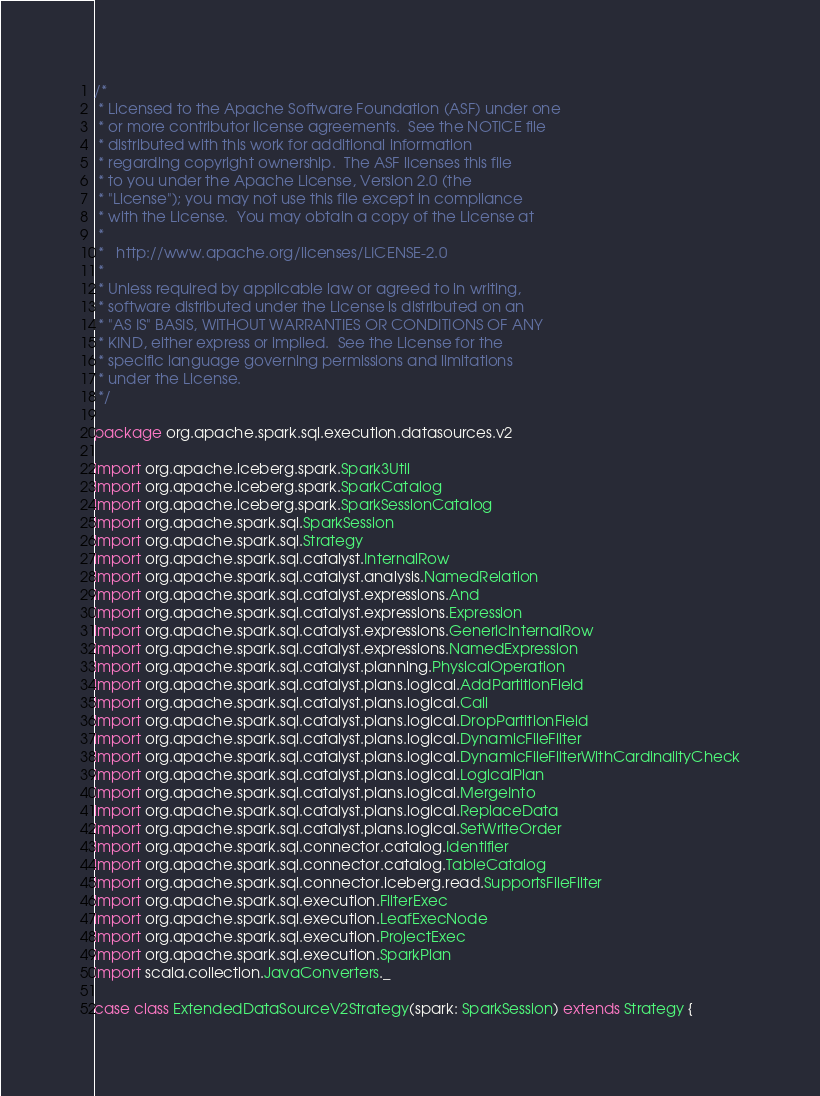Convert code to text. <code><loc_0><loc_0><loc_500><loc_500><_Scala_>/*
 * Licensed to the Apache Software Foundation (ASF) under one
 * or more contributor license agreements.  See the NOTICE file
 * distributed with this work for additional information
 * regarding copyright ownership.  The ASF licenses this file
 * to you under the Apache License, Version 2.0 (the
 * "License"); you may not use this file except in compliance
 * with the License.  You may obtain a copy of the License at
 *
 *   http://www.apache.org/licenses/LICENSE-2.0
 *
 * Unless required by applicable law or agreed to in writing,
 * software distributed under the License is distributed on an
 * "AS IS" BASIS, WITHOUT WARRANTIES OR CONDITIONS OF ANY
 * KIND, either express or implied.  See the License for the
 * specific language governing permissions and limitations
 * under the License.
 */

package org.apache.spark.sql.execution.datasources.v2

import org.apache.iceberg.spark.Spark3Util
import org.apache.iceberg.spark.SparkCatalog
import org.apache.iceberg.spark.SparkSessionCatalog
import org.apache.spark.sql.SparkSession
import org.apache.spark.sql.Strategy
import org.apache.spark.sql.catalyst.InternalRow
import org.apache.spark.sql.catalyst.analysis.NamedRelation
import org.apache.spark.sql.catalyst.expressions.And
import org.apache.spark.sql.catalyst.expressions.Expression
import org.apache.spark.sql.catalyst.expressions.GenericInternalRow
import org.apache.spark.sql.catalyst.expressions.NamedExpression
import org.apache.spark.sql.catalyst.planning.PhysicalOperation
import org.apache.spark.sql.catalyst.plans.logical.AddPartitionField
import org.apache.spark.sql.catalyst.plans.logical.Call
import org.apache.spark.sql.catalyst.plans.logical.DropPartitionField
import org.apache.spark.sql.catalyst.plans.logical.DynamicFileFilter
import org.apache.spark.sql.catalyst.plans.logical.DynamicFileFilterWithCardinalityCheck
import org.apache.spark.sql.catalyst.plans.logical.LogicalPlan
import org.apache.spark.sql.catalyst.plans.logical.MergeInto
import org.apache.spark.sql.catalyst.plans.logical.ReplaceData
import org.apache.spark.sql.catalyst.plans.logical.SetWriteOrder
import org.apache.spark.sql.connector.catalog.Identifier
import org.apache.spark.sql.connector.catalog.TableCatalog
import org.apache.spark.sql.connector.iceberg.read.SupportsFileFilter
import org.apache.spark.sql.execution.FilterExec
import org.apache.spark.sql.execution.LeafExecNode
import org.apache.spark.sql.execution.ProjectExec
import org.apache.spark.sql.execution.SparkPlan
import scala.collection.JavaConverters._

case class ExtendedDataSourceV2Strategy(spark: SparkSession) extends Strategy {
</code> 